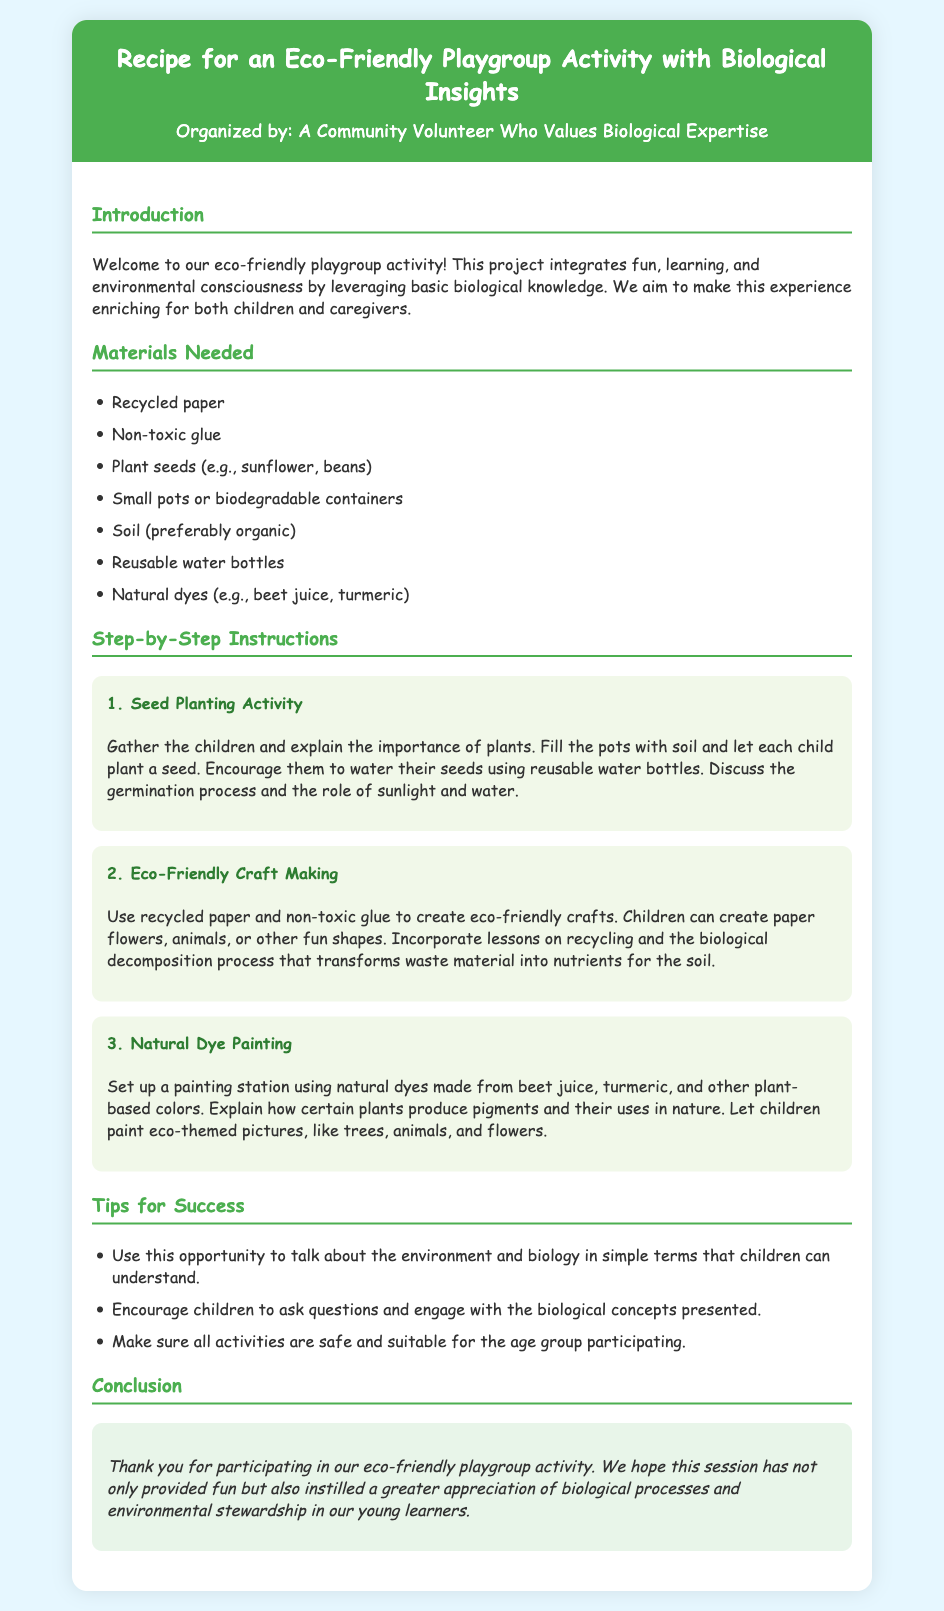What is the title of the recipe? The title can be found at the top of the document, indicating the main focus of the activity.
Answer: Recipe for an Eco-Friendly Playgroup Activity with Biological Insights Who organized the activity? The organizer is mentioned right below the title, highlighting their involvement.
Answer: A Community Volunteer Who Values Biological Expertise What materials are needed for the seed planting activity? The materials required for this specific activity are listed under the "Materials Needed" section.
Answer: Plant seeds (e.g., sunflower, beans) Which color is used for the header background? The header background color is specified in the document to create a visually appealing design.
Answer: #4CAF50 What is the first step outlined in the instructions? The steps are presented in a sequential order, allowing easy identification of the first one.
Answer: Seed Planting Activity What type of glue is mentioned? The type of glue is specified under the materials needed, indicating its non-toxic nature.
Answer: Non-toxic glue What lesson is incorporated during the eco-friendly craft making? The lesson is directly related to the activities and provides educational context during crafting.
Answer: Recycling and the biological decomposition process What is suggested to ensure activities are safe for children? The document advises checking the suitability of activities for the participants’ age group.
Answer: Make sure all activities are safe and suitable for the age group participating What does the conclusion express gratitude for? The conclusion thanks participants for their involvement in a specific type of activity.
Answer: Participating in our eco-friendly playgroup activity 